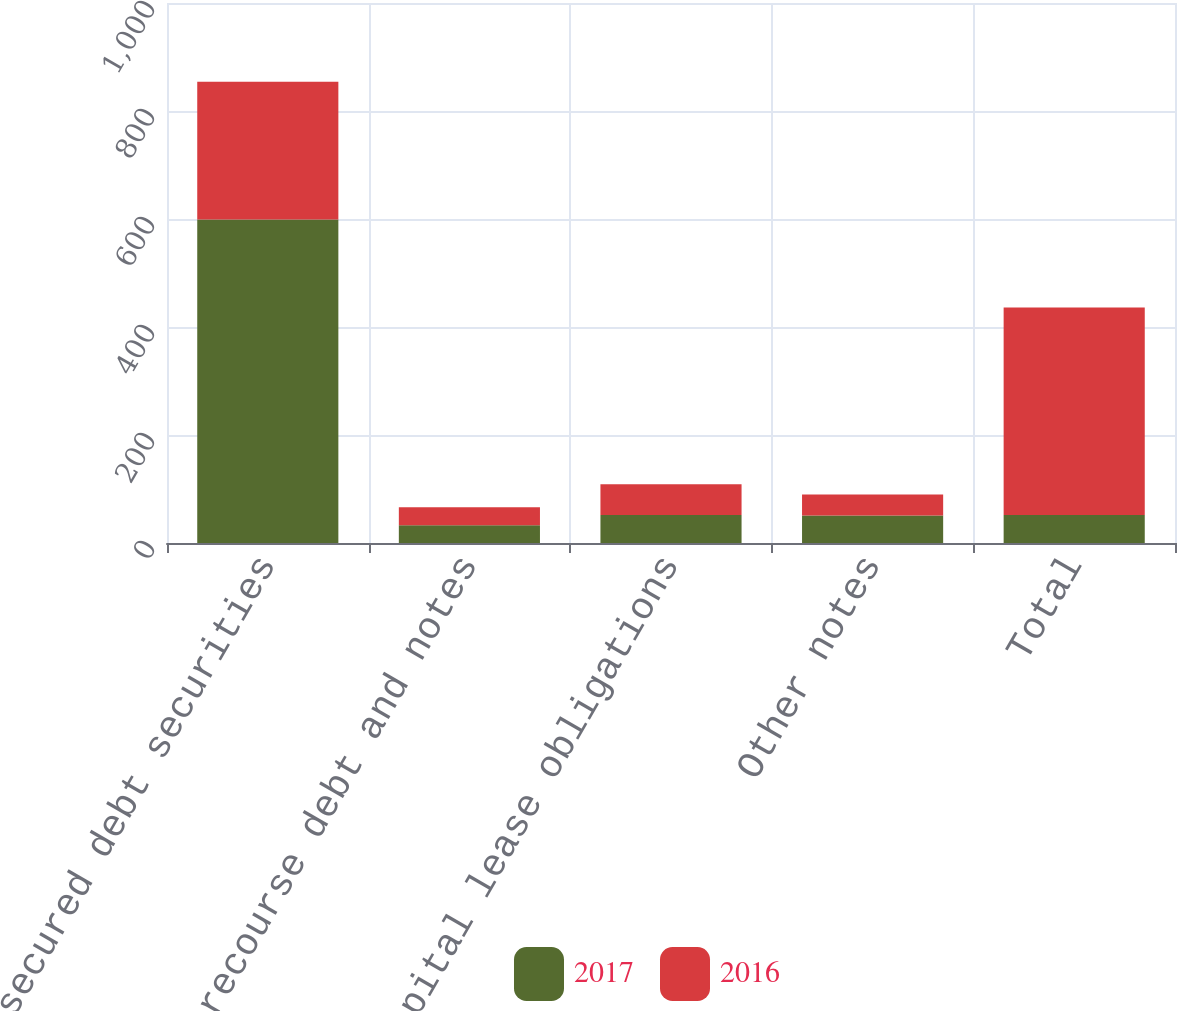Convert chart. <chart><loc_0><loc_0><loc_500><loc_500><stacked_bar_chart><ecel><fcel>Unsecured debt securities<fcel>Non-recourse debt and notes<fcel>Capital lease obligations<fcel>Other notes<fcel>Total<nl><fcel>2017<fcel>599<fcel>33<fcel>52<fcel>51<fcel>52<nl><fcel>2016<fcel>255<fcel>33<fcel>57<fcel>39<fcel>384<nl></chart> 